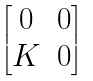Convert formula to latex. <formula><loc_0><loc_0><loc_500><loc_500>\begin{bmatrix} 0 & 0 \\ K & 0 \end{bmatrix}</formula> 